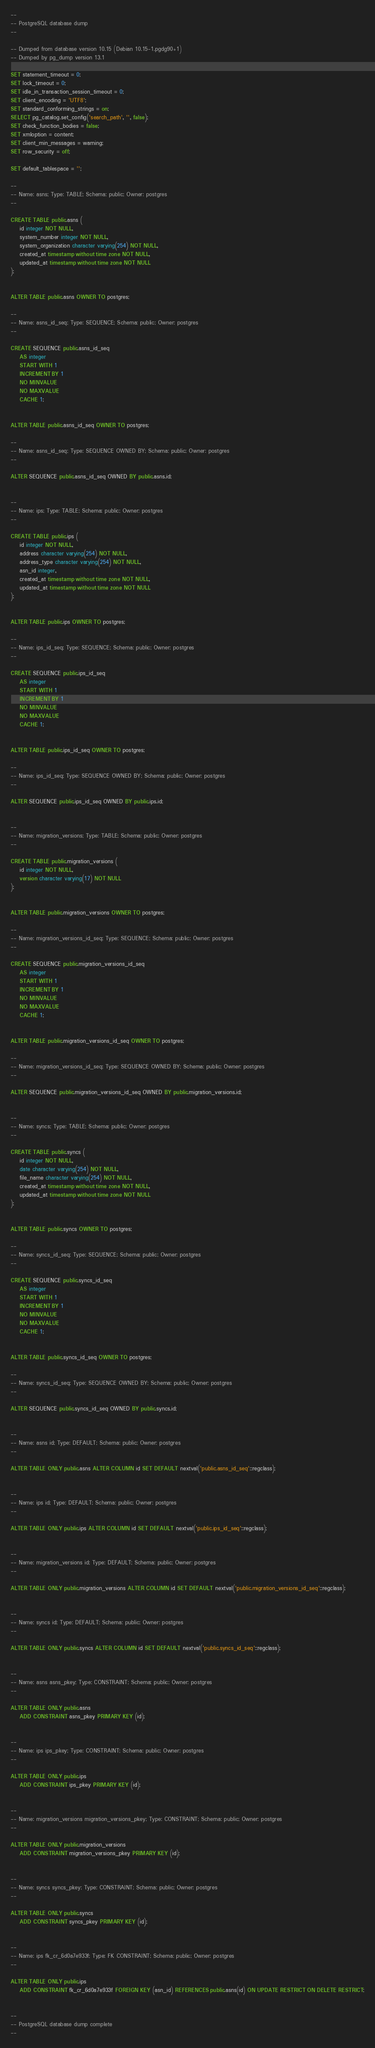Convert code to text. <code><loc_0><loc_0><loc_500><loc_500><_SQL_>--
-- PostgreSQL database dump
--

-- Dumped from database version 10.15 (Debian 10.15-1.pgdg90+1)
-- Dumped by pg_dump version 13.1

SET statement_timeout = 0;
SET lock_timeout = 0;
SET idle_in_transaction_session_timeout = 0;
SET client_encoding = 'UTF8';
SET standard_conforming_strings = on;
SELECT pg_catalog.set_config('search_path', '', false);
SET check_function_bodies = false;
SET xmloption = content;
SET client_min_messages = warning;
SET row_security = off;

SET default_tablespace = '';

--
-- Name: asns; Type: TABLE; Schema: public; Owner: postgres
--

CREATE TABLE public.asns (
    id integer NOT NULL,
    system_number integer NOT NULL,
    system_organization character varying(254) NOT NULL,
    created_at timestamp without time zone NOT NULL,
    updated_at timestamp without time zone NOT NULL
);


ALTER TABLE public.asns OWNER TO postgres;

--
-- Name: asns_id_seq; Type: SEQUENCE; Schema: public; Owner: postgres
--

CREATE SEQUENCE public.asns_id_seq
    AS integer
    START WITH 1
    INCREMENT BY 1
    NO MINVALUE
    NO MAXVALUE
    CACHE 1;


ALTER TABLE public.asns_id_seq OWNER TO postgres;

--
-- Name: asns_id_seq; Type: SEQUENCE OWNED BY; Schema: public; Owner: postgres
--

ALTER SEQUENCE public.asns_id_seq OWNED BY public.asns.id;


--
-- Name: ips; Type: TABLE; Schema: public; Owner: postgres
--

CREATE TABLE public.ips (
    id integer NOT NULL,
    address character varying(254) NOT NULL,
    address_type character varying(254) NOT NULL,
    asn_id integer,
    created_at timestamp without time zone NOT NULL,
    updated_at timestamp without time zone NOT NULL
);


ALTER TABLE public.ips OWNER TO postgres;

--
-- Name: ips_id_seq; Type: SEQUENCE; Schema: public; Owner: postgres
--

CREATE SEQUENCE public.ips_id_seq
    AS integer
    START WITH 1
    INCREMENT BY 1
    NO MINVALUE
    NO MAXVALUE
    CACHE 1;


ALTER TABLE public.ips_id_seq OWNER TO postgres;

--
-- Name: ips_id_seq; Type: SEQUENCE OWNED BY; Schema: public; Owner: postgres
--

ALTER SEQUENCE public.ips_id_seq OWNED BY public.ips.id;


--
-- Name: migration_versions; Type: TABLE; Schema: public; Owner: postgres
--

CREATE TABLE public.migration_versions (
    id integer NOT NULL,
    version character varying(17) NOT NULL
);


ALTER TABLE public.migration_versions OWNER TO postgres;

--
-- Name: migration_versions_id_seq; Type: SEQUENCE; Schema: public; Owner: postgres
--

CREATE SEQUENCE public.migration_versions_id_seq
    AS integer
    START WITH 1
    INCREMENT BY 1
    NO MINVALUE
    NO MAXVALUE
    CACHE 1;


ALTER TABLE public.migration_versions_id_seq OWNER TO postgres;

--
-- Name: migration_versions_id_seq; Type: SEQUENCE OWNED BY; Schema: public; Owner: postgres
--

ALTER SEQUENCE public.migration_versions_id_seq OWNED BY public.migration_versions.id;


--
-- Name: syncs; Type: TABLE; Schema: public; Owner: postgres
--

CREATE TABLE public.syncs (
    id integer NOT NULL,
    date character varying(254) NOT NULL,
    file_name character varying(254) NOT NULL,
    created_at timestamp without time zone NOT NULL,
    updated_at timestamp without time zone NOT NULL
);


ALTER TABLE public.syncs OWNER TO postgres;

--
-- Name: syncs_id_seq; Type: SEQUENCE; Schema: public; Owner: postgres
--

CREATE SEQUENCE public.syncs_id_seq
    AS integer
    START WITH 1
    INCREMENT BY 1
    NO MINVALUE
    NO MAXVALUE
    CACHE 1;


ALTER TABLE public.syncs_id_seq OWNER TO postgres;

--
-- Name: syncs_id_seq; Type: SEQUENCE OWNED BY; Schema: public; Owner: postgres
--

ALTER SEQUENCE public.syncs_id_seq OWNED BY public.syncs.id;


--
-- Name: asns id; Type: DEFAULT; Schema: public; Owner: postgres
--

ALTER TABLE ONLY public.asns ALTER COLUMN id SET DEFAULT nextval('public.asns_id_seq'::regclass);


--
-- Name: ips id; Type: DEFAULT; Schema: public; Owner: postgres
--

ALTER TABLE ONLY public.ips ALTER COLUMN id SET DEFAULT nextval('public.ips_id_seq'::regclass);


--
-- Name: migration_versions id; Type: DEFAULT; Schema: public; Owner: postgres
--

ALTER TABLE ONLY public.migration_versions ALTER COLUMN id SET DEFAULT nextval('public.migration_versions_id_seq'::regclass);


--
-- Name: syncs id; Type: DEFAULT; Schema: public; Owner: postgres
--

ALTER TABLE ONLY public.syncs ALTER COLUMN id SET DEFAULT nextval('public.syncs_id_seq'::regclass);


--
-- Name: asns asns_pkey; Type: CONSTRAINT; Schema: public; Owner: postgres
--

ALTER TABLE ONLY public.asns
    ADD CONSTRAINT asns_pkey PRIMARY KEY (id);


--
-- Name: ips ips_pkey; Type: CONSTRAINT; Schema: public; Owner: postgres
--

ALTER TABLE ONLY public.ips
    ADD CONSTRAINT ips_pkey PRIMARY KEY (id);


--
-- Name: migration_versions migration_versions_pkey; Type: CONSTRAINT; Schema: public; Owner: postgres
--

ALTER TABLE ONLY public.migration_versions
    ADD CONSTRAINT migration_versions_pkey PRIMARY KEY (id);


--
-- Name: syncs syncs_pkey; Type: CONSTRAINT; Schema: public; Owner: postgres
--

ALTER TABLE ONLY public.syncs
    ADD CONSTRAINT syncs_pkey PRIMARY KEY (id);


--
-- Name: ips fk_cr_6d0a7e933f; Type: FK CONSTRAINT; Schema: public; Owner: postgres
--

ALTER TABLE ONLY public.ips
    ADD CONSTRAINT fk_cr_6d0a7e933f FOREIGN KEY (asn_id) REFERENCES public.asns(id) ON UPDATE RESTRICT ON DELETE RESTRICT;


--
-- PostgreSQL database dump complete
--

</code> 